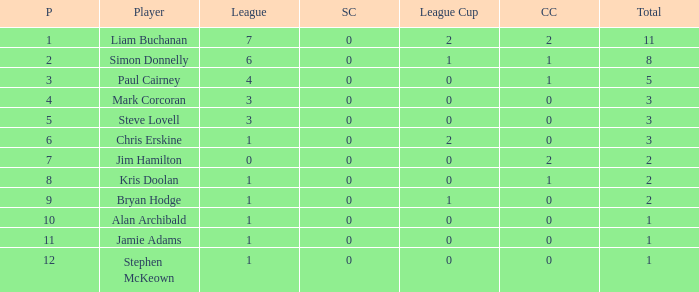How many points did player 7 score in the challenge cup? 1.0. 